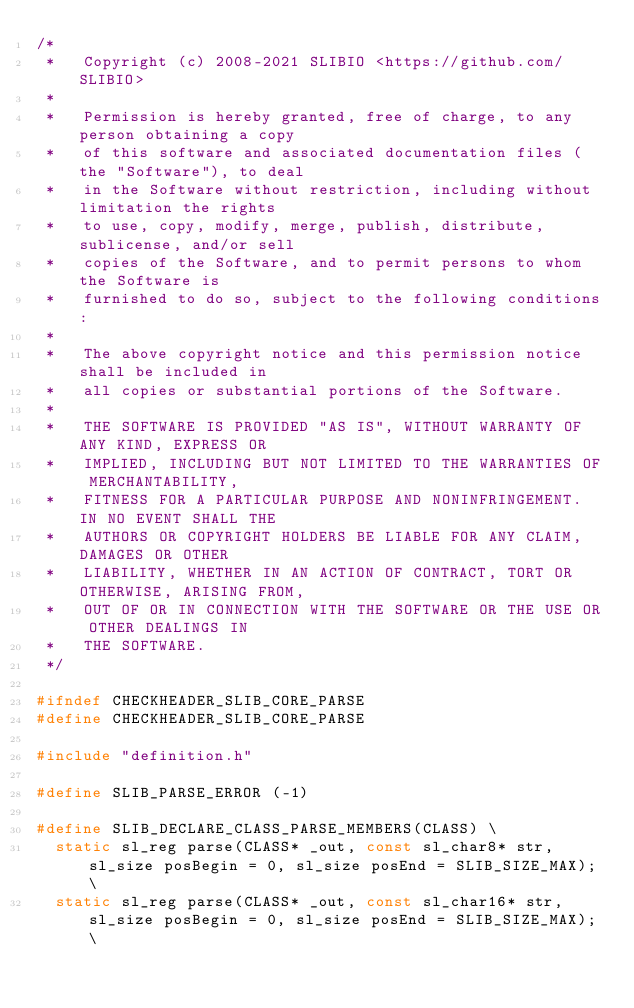<code> <loc_0><loc_0><loc_500><loc_500><_C_>/*
 *   Copyright (c) 2008-2021 SLIBIO <https://github.com/SLIBIO>
 *
 *   Permission is hereby granted, free of charge, to any person obtaining a copy
 *   of this software and associated documentation files (the "Software"), to deal
 *   in the Software without restriction, including without limitation the rights
 *   to use, copy, modify, merge, publish, distribute, sublicense, and/or sell
 *   copies of the Software, and to permit persons to whom the Software is
 *   furnished to do so, subject to the following conditions:
 *
 *   The above copyright notice and this permission notice shall be included in
 *   all copies or substantial portions of the Software.
 *
 *   THE SOFTWARE IS PROVIDED "AS IS", WITHOUT WARRANTY OF ANY KIND, EXPRESS OR
 *   IMPLIED, INCLUDING BUT NOT LIMITED TO THE WARRANTIES OF MERCHANTABILITY,
 *   FITNESS FOR A PARTICULAR PURPOSE AND NONINFRINGEMENT. IN NO EVENT SHALL THE
 *   AUTHORS OR COPYRIGHT HOLDERS BE LIABLE FOR ANY CLAIM, DAMAGES OR OTHER
 *   LIABILITY, WHETHER IN AN ACTION OF CONTRACT, TORT OR OTHERWISE, ARISING FROM,
 *   OUT OF OR IN CONNECTION WITH THE SOFTWARE OR THE USE OR OTHER DEALINGS IN
 *   THE SOFTWARE.
 */

#ifndef CHECKHEADER_SLIB_CORE_PARSE
#define CHECKHEADER_SLIB_CORE_PARSE

#include "definition.h"

#define SLIB_PARSE_ERROR (-1)

#define SLIB_DECLARE_CLASS_PARSE_MEMBERS(CLASS) \
	static sl_reg parse(CLASS* _out, const sl_char8* str, sl_size posBegin = 0, sl_size posEnd = SLIB_SIZE_MAX); \
	static sl_reg parse(CLASS* _out, const sl_char16* str, sl_size posBegin = 0, sl_size posEnd = SLIB_SIZE_MAX); \</code> 